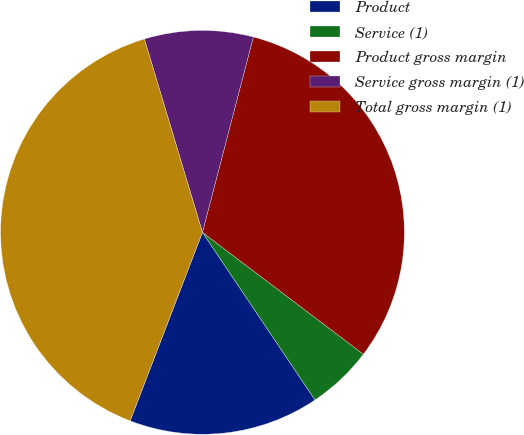Convert chart. <chart><loc_0><loc_0><loc_500><loc_500><pie_chart><fcel>Product<fcel>Service (1)<fcel>Product gross margin<fcel>Service gross margin (1)<fcel>Total gross margin (1)<nl><fcel>15.24%<fcel>5.27%<fcel>31.26%<fcel>8.7%<fcel>39.53%<nl></chart> 